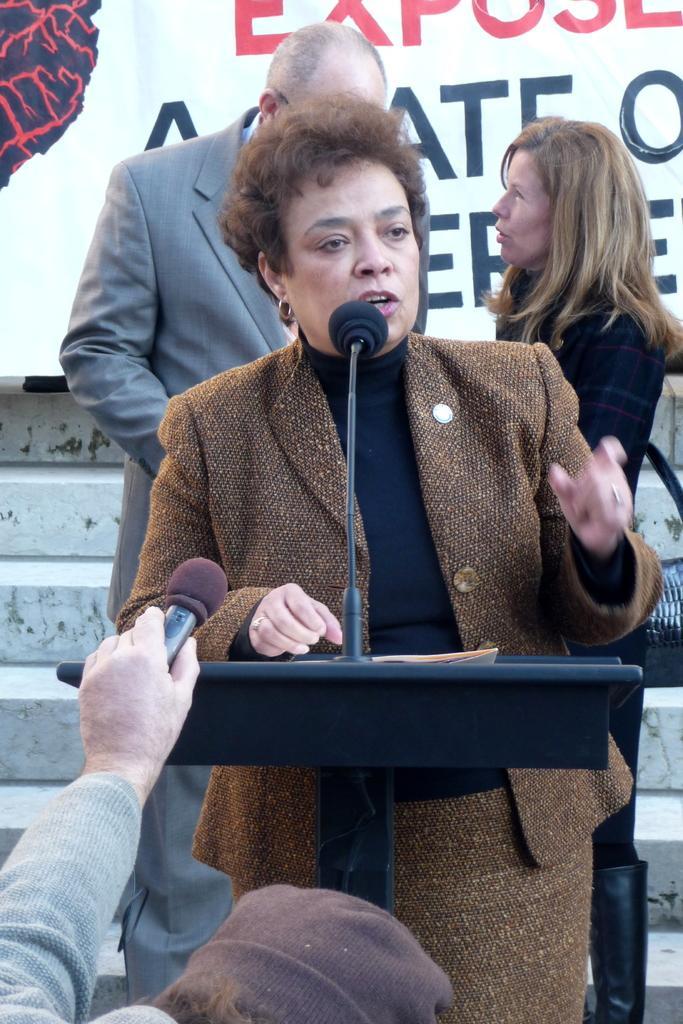In one or two sentences, can you explain what this image depicts? In this image there is a lady standing and talking in a microphone, behind her there are two other people standing and also there is a banner, in front of her there is a person holding mic in hands. 